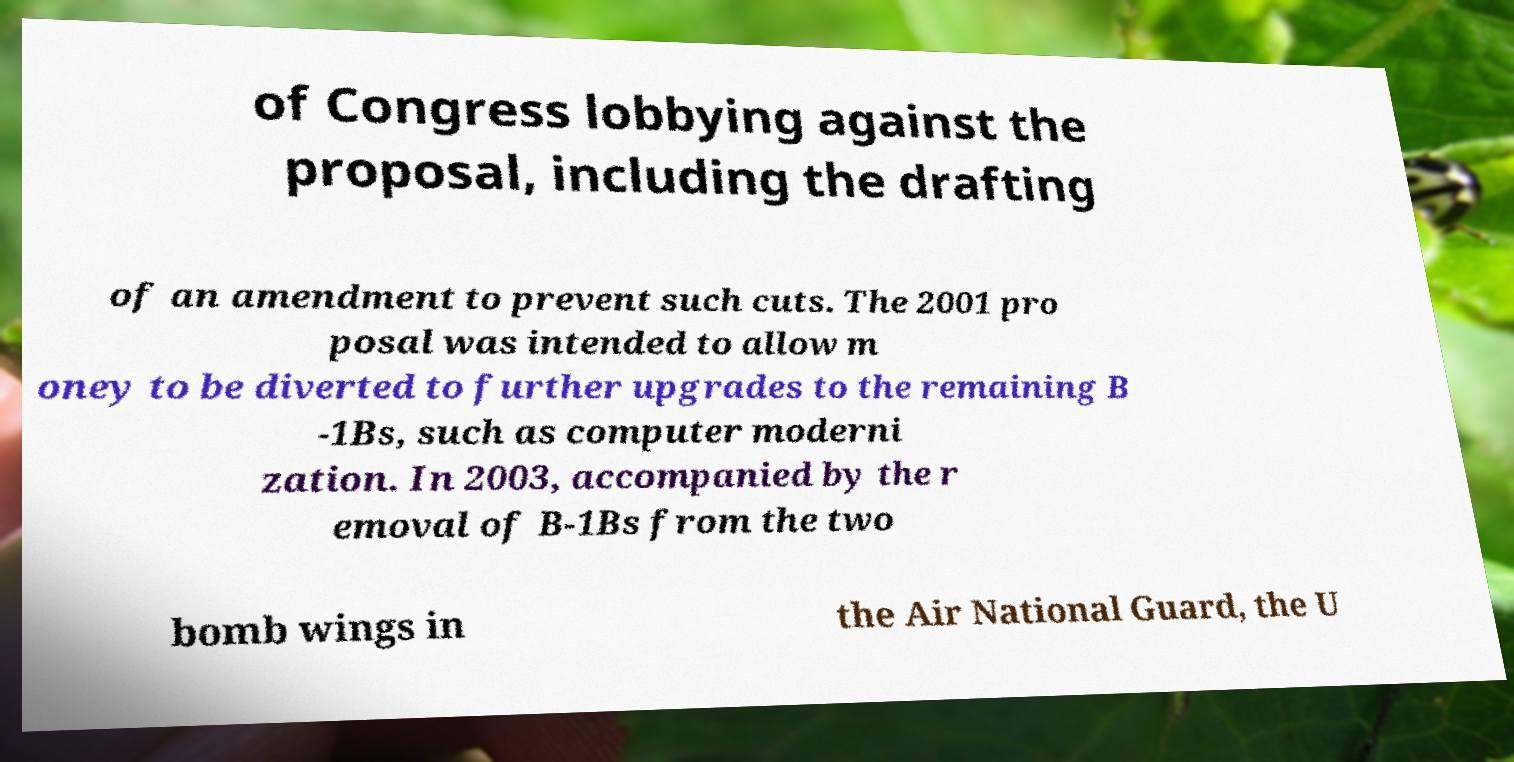Please read and relay the text visible in this image. What does it say? of Congress lobbying against the proposal, including the drafting of an amendment to prevent such cuts. The 2001 pro posal was intended to allow m oney to be diverted to further upgrades to the remaining B -1Bs, such as computer moderni zation. In 2003, accompanied by the r emoval of B-1Bs from the two bomb wings in the Air National Guard, the U 